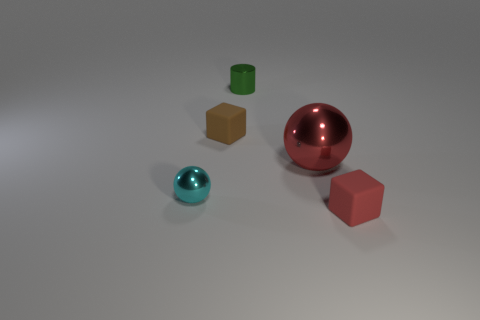Are there any other things that have the same size as the brown object?
Keep it short and to the point. Yes. What is the material of the object left of the small matte cube that is on the left side of the small metallic thing behind the tiny sphere?
Provide a short and direct response. Metal. Are there more red things to the left of the cyan shiny thing than tiny cylinders in front of the tiny red block?
Make the answer very short. No. Do the brown block and the cylinder have the same size?
Your answer should be compact. Yes. The other small matte object that is the same shape as the small red matte thing is what color?
Your response must be concise. Brown. How many other big things have the same color as the large object?
Offer a very short reply. 0. Are there more cyan balls that are left of the tiny brown thing than large things?
Provide a succinct answer. No. There is a tiny rubber object that is in front of the sphere that is on the right side of the tiny cylinder; what is its color?
Keep it short and to the point. Red. How many objects are objects that are to the right of the small brown block or blocks behind the tiny metal ball?
Offer a terse response. 4. What is the color of the large metal object?
Offer a terse response. Red. 